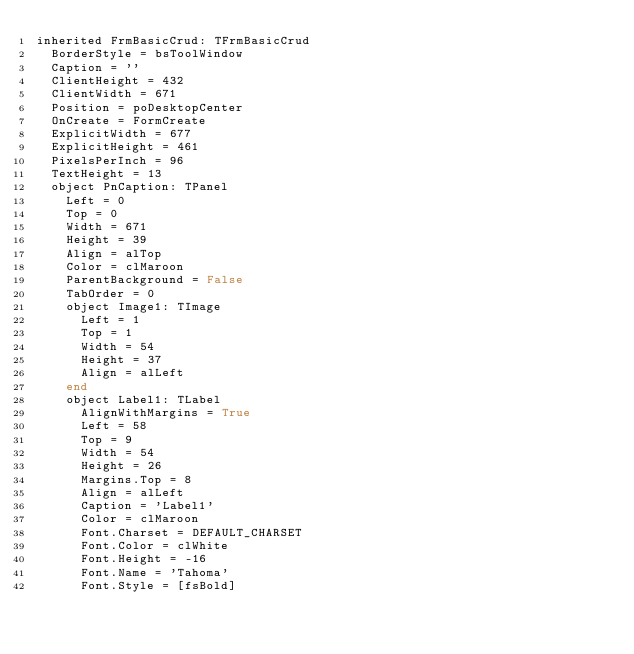<code> <loc_0><loc_0><loc_500><loc_500><_Pascal_>inherited FrmBasicCrud: TFrmBasicCrud
  BorderStyle = bsToolWindow
  Caption = ''
  ClientHeight = 432
  ClientWidth = 671
  Position = poDesktopCenter
  OnCreate = FormCreate
  ExplicitWidth = 677
  ExplicitHeight = 461
  PixelsPerInch = 96
  TextHeight = 13
  object PnCaption: TPanel
    Left = 0
    Top = 0
    Width = 671
    Height = 39
    Align = alTop
    Color = clMaroon
    ParentBackground = False
    TabOrder = 0
    object Image1: TImage
      Left = 1
      Top = 1
      Width = 54
      Height = 37
      Align = alLeft
    end
    object Label1: TLabel
      AlignWithMargins = True
      Left = 58
      Top = 9
      Width = 54
      Height = 26
      Margins.Top = 8
      Align = alLeft
      Caption = 'Label1'
      Color = clMaroon
      Font.Charset = DEFAULT_CHARSET
      Font.Color = clWhite
      Font.Height = -16
      Font.Name = 'Tahoma'
      Font.Style = [fsBold]</code> 